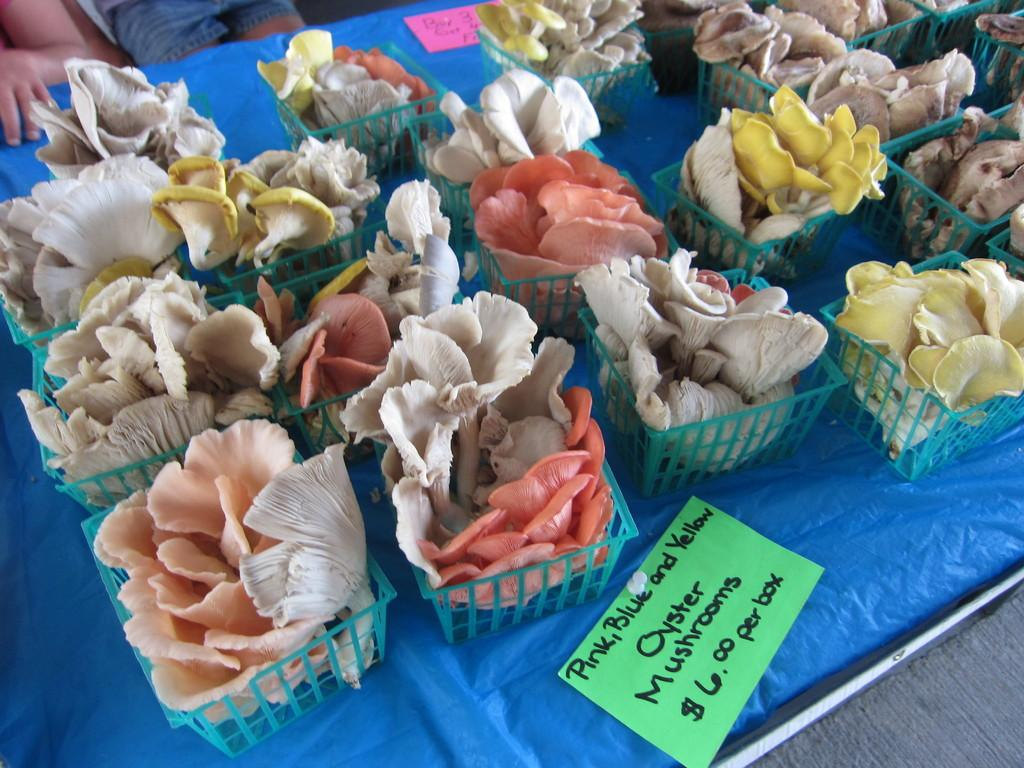What are the mushrooms placed in? The mushrooms are placed in bowls. What can be seen on the table in the image? There is a price tag on the table. Can you describe the people in the image? There are two people at the top left side of the image. What type of scent can be detected from the mushrooms in the image? There is no indication of a scent in the image, as it only shows mushrooms placed in bowls and a price tag on the table. 